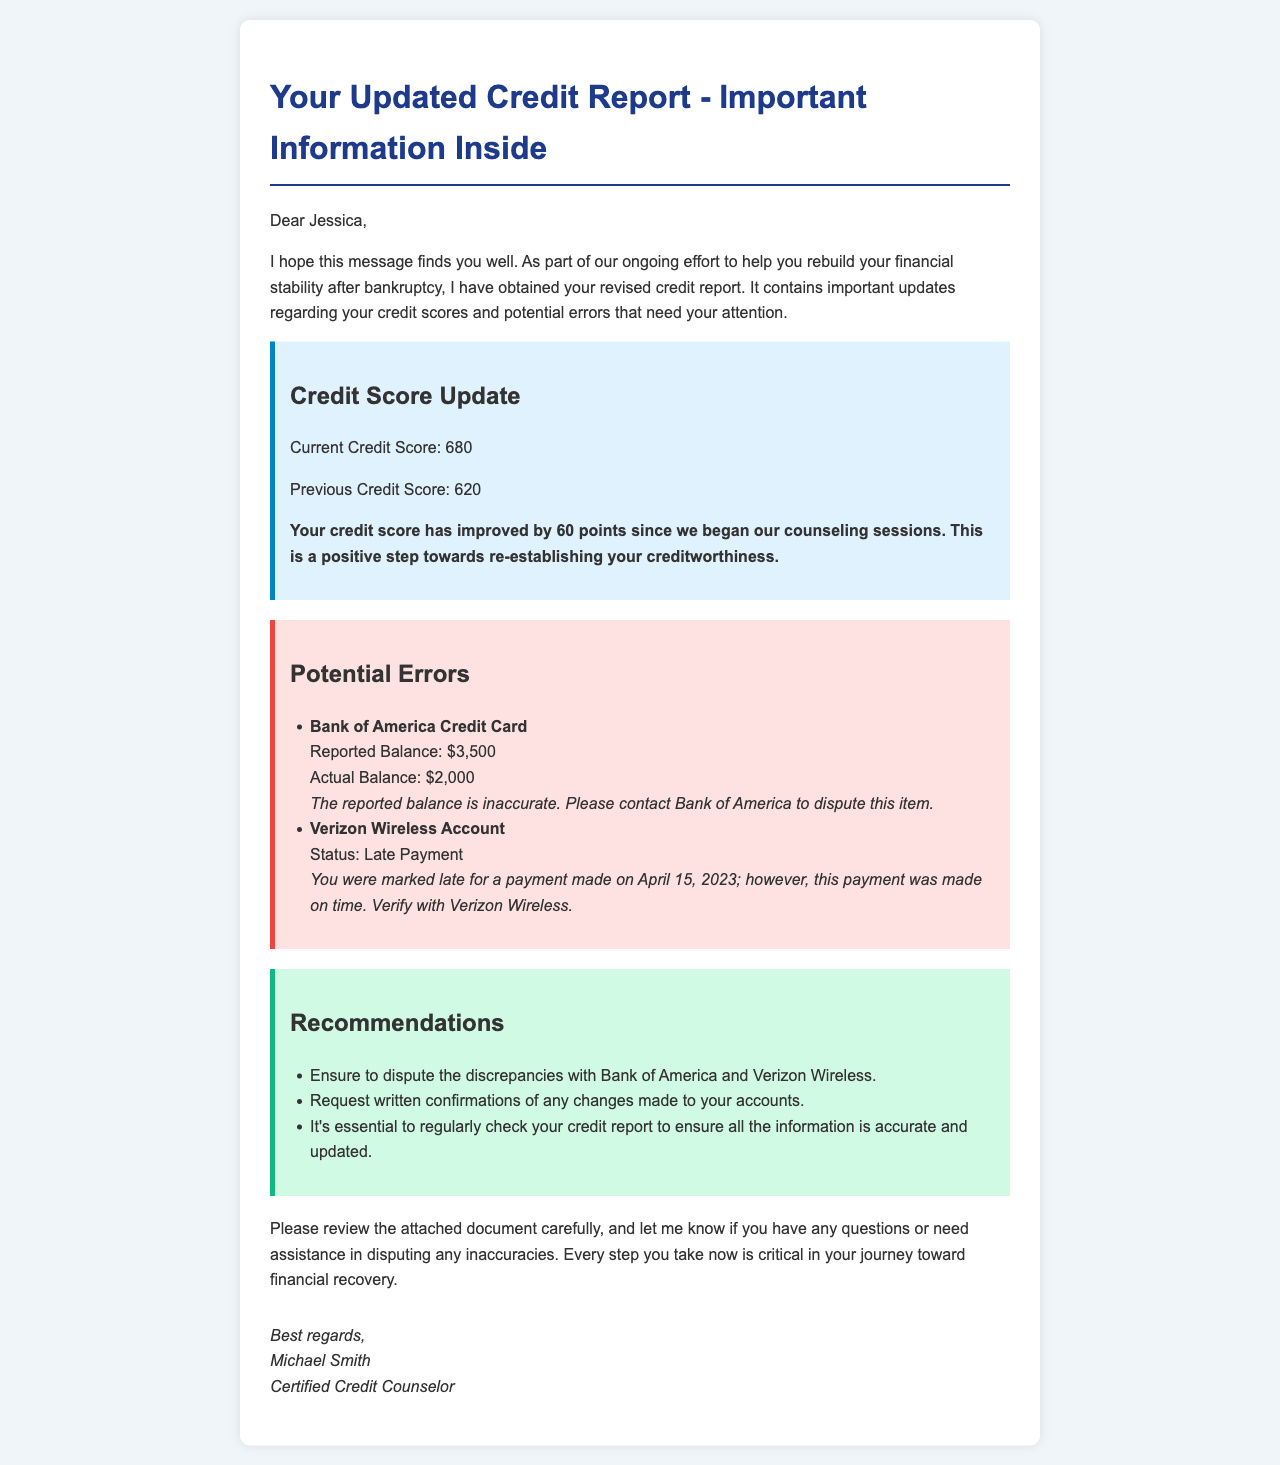What is the current credit score? The current credit score is explicitly stated in the document as 680.
Answer: 680 What was the previous credit score? The previous credit score is provided in the document as 620.
Answer: 620 Who is the sender of the email? The sender of the email is mentioned at the end of the document as Michael Smith, Certified Credit Counselor.
Answer: Michael Smith What is the error reported by Bank of America? The error related to Bank of America is a discrepancy in the reported balance compared to the actual balance.
Answer: Inaccurate reported balance When was the late payment reported by Verizon Wireless? The document specifies that the late payment was reported for April 15, 2023.
Answer: April 15, 2023 How much did the credit score improve? The document states that the credit score improved by 60 points since the beginning of the counseling sessions.
Answer: 60 points What should be requested from the financial accounts? The document recommends requesting written confirmations of any changes made to the accounts.
Answer: Written confirmations What are clients advised to do regularly? Clients are advised to regularly check their credit report to ensure information is accurate and updated.
Answer: Regularly check credit report 